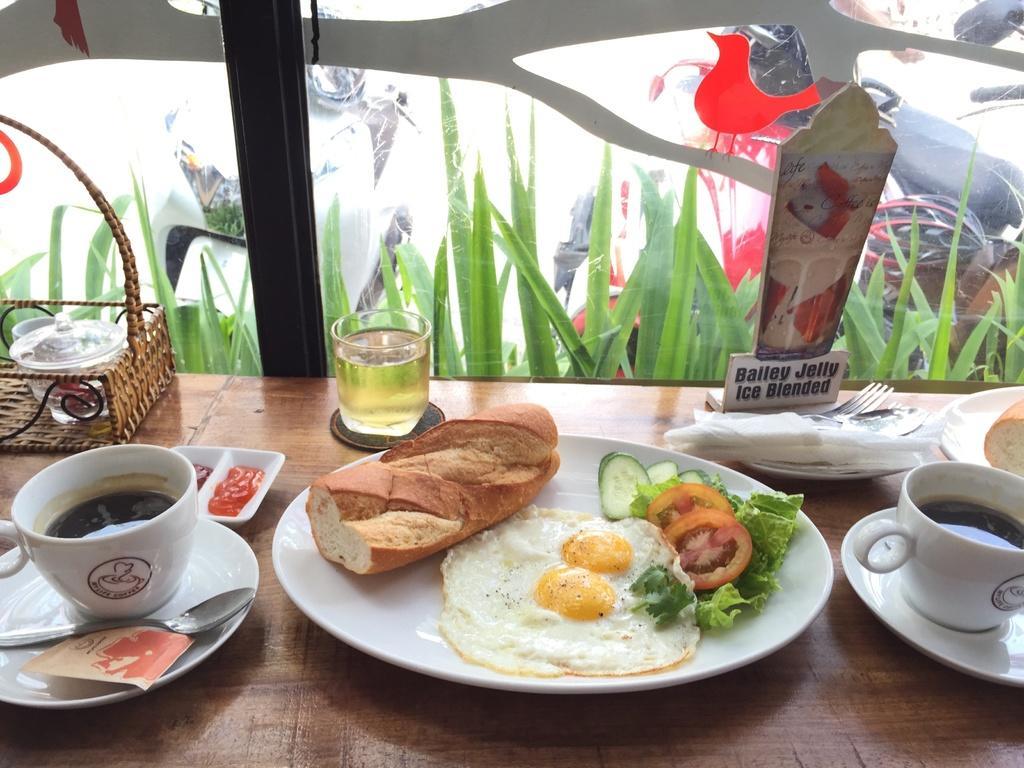In one or two sentences, can you explain what this image depicts? We can see plates, cups, spoons, fork, tomato and cucumber slices, bread, food, basket, tissue papers and objects on the table. We can see glass, through this glass we can see plants and vehicles and we can see painting on glass. 